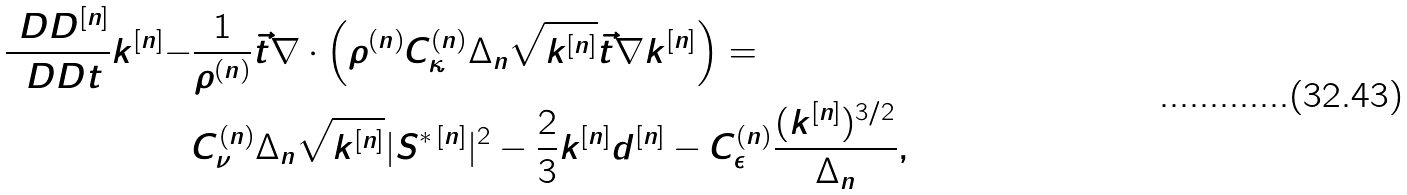<formula> <loc_0><loc_0><loc_500><loc_500>\frac { \ D D ^ { [ n ] } } { \ D D t } k ^ { [ n ] } - & \frac { 1 } { \rho ^ { ( n ) } } \vec { t } { \nabla } \cdot \left ( \rho ^ { ( n ) } C _ { \kappa } ^ { ( n ) } \Delta _ { n } \sqrt { k ^ { [ n ] } } \vec { t } { \nabla } k ^ { [ n ] } \right ) = \\ & C _ { \nu } ^ { ( n ) } \Delta _ { n } \sqrt { k ^ { [ n ] } } | S ^ { \ast \, [ n ] } | ^ { 2 } - \frac { 2 } { 3 } k ^ { [ n ] } d ^ { [ n ] } - C _ { \epsilon } ^ { ( n ) } \frac { ( k ^ { [ n ] } ) ^ { 3 / 2 } } { \Delta _ { n } } ,</formula> 